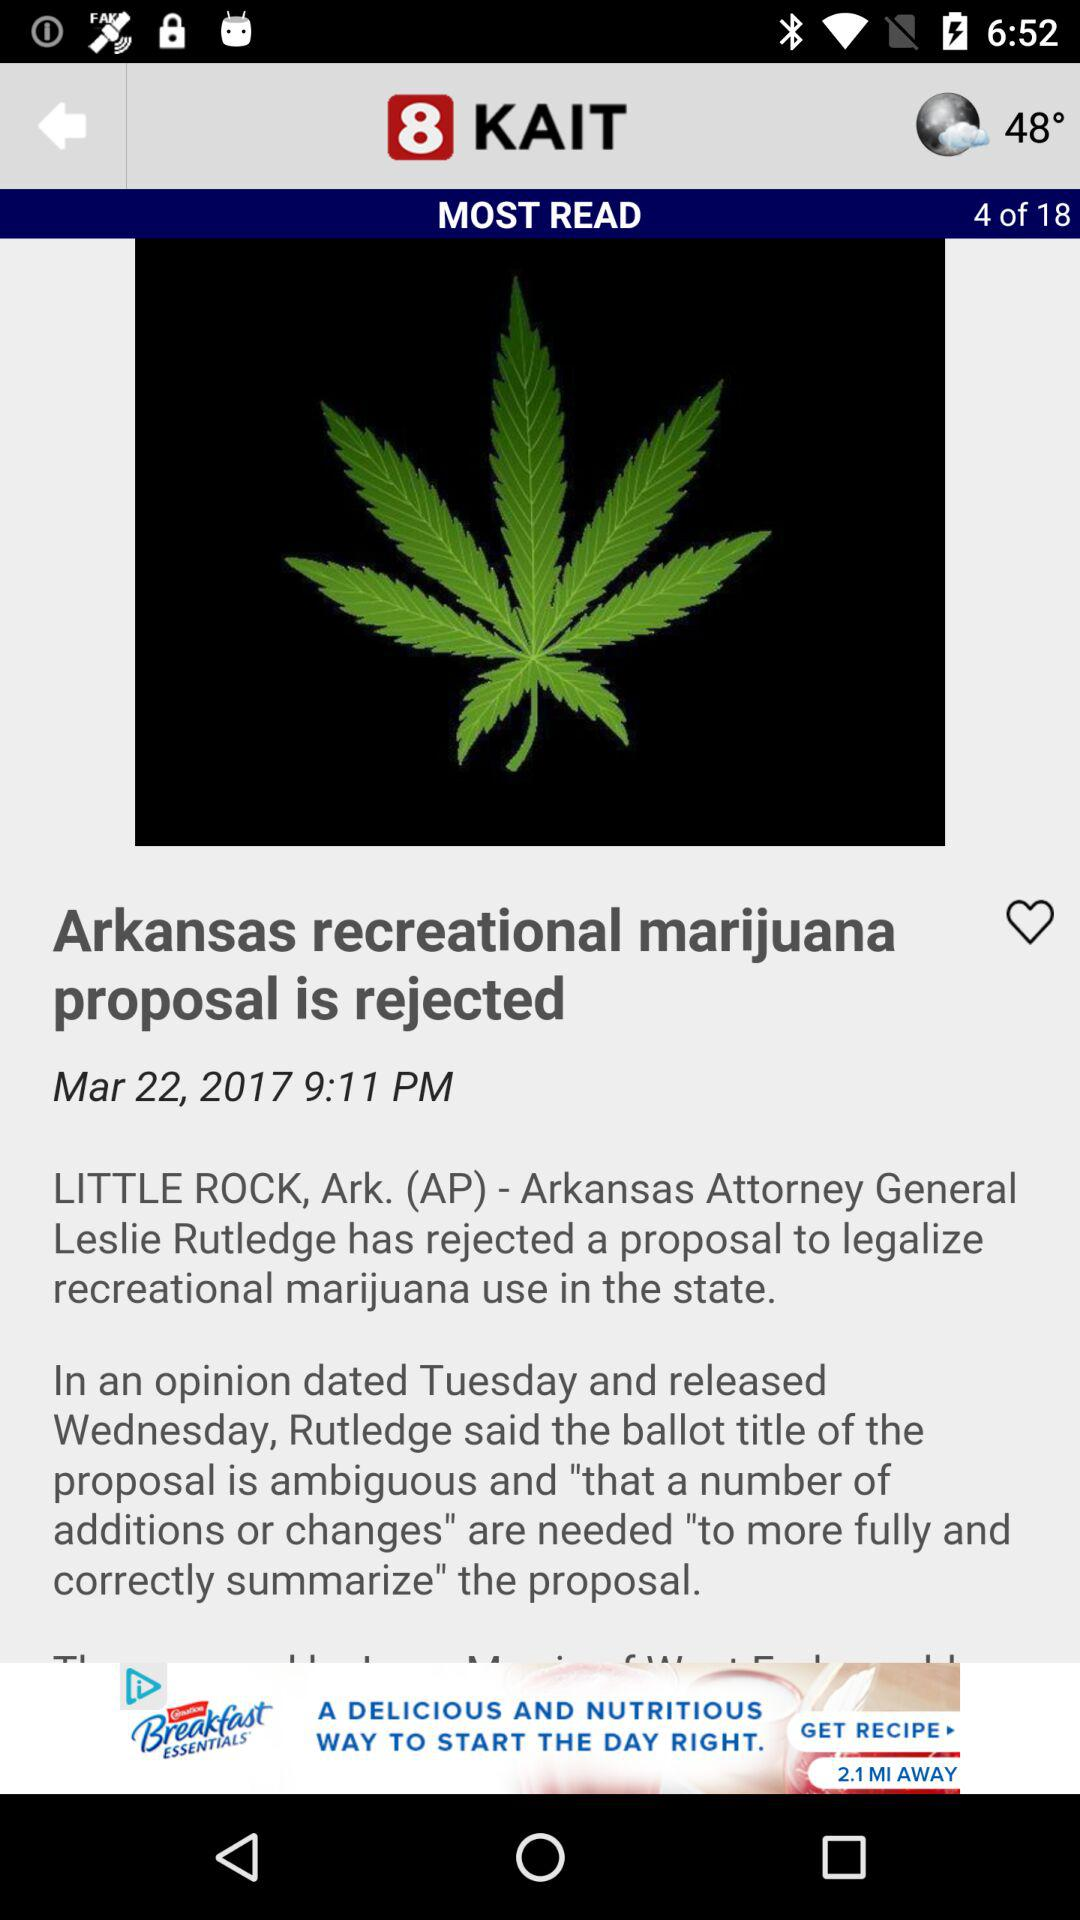What is the temperature? The temperature is 48°. 